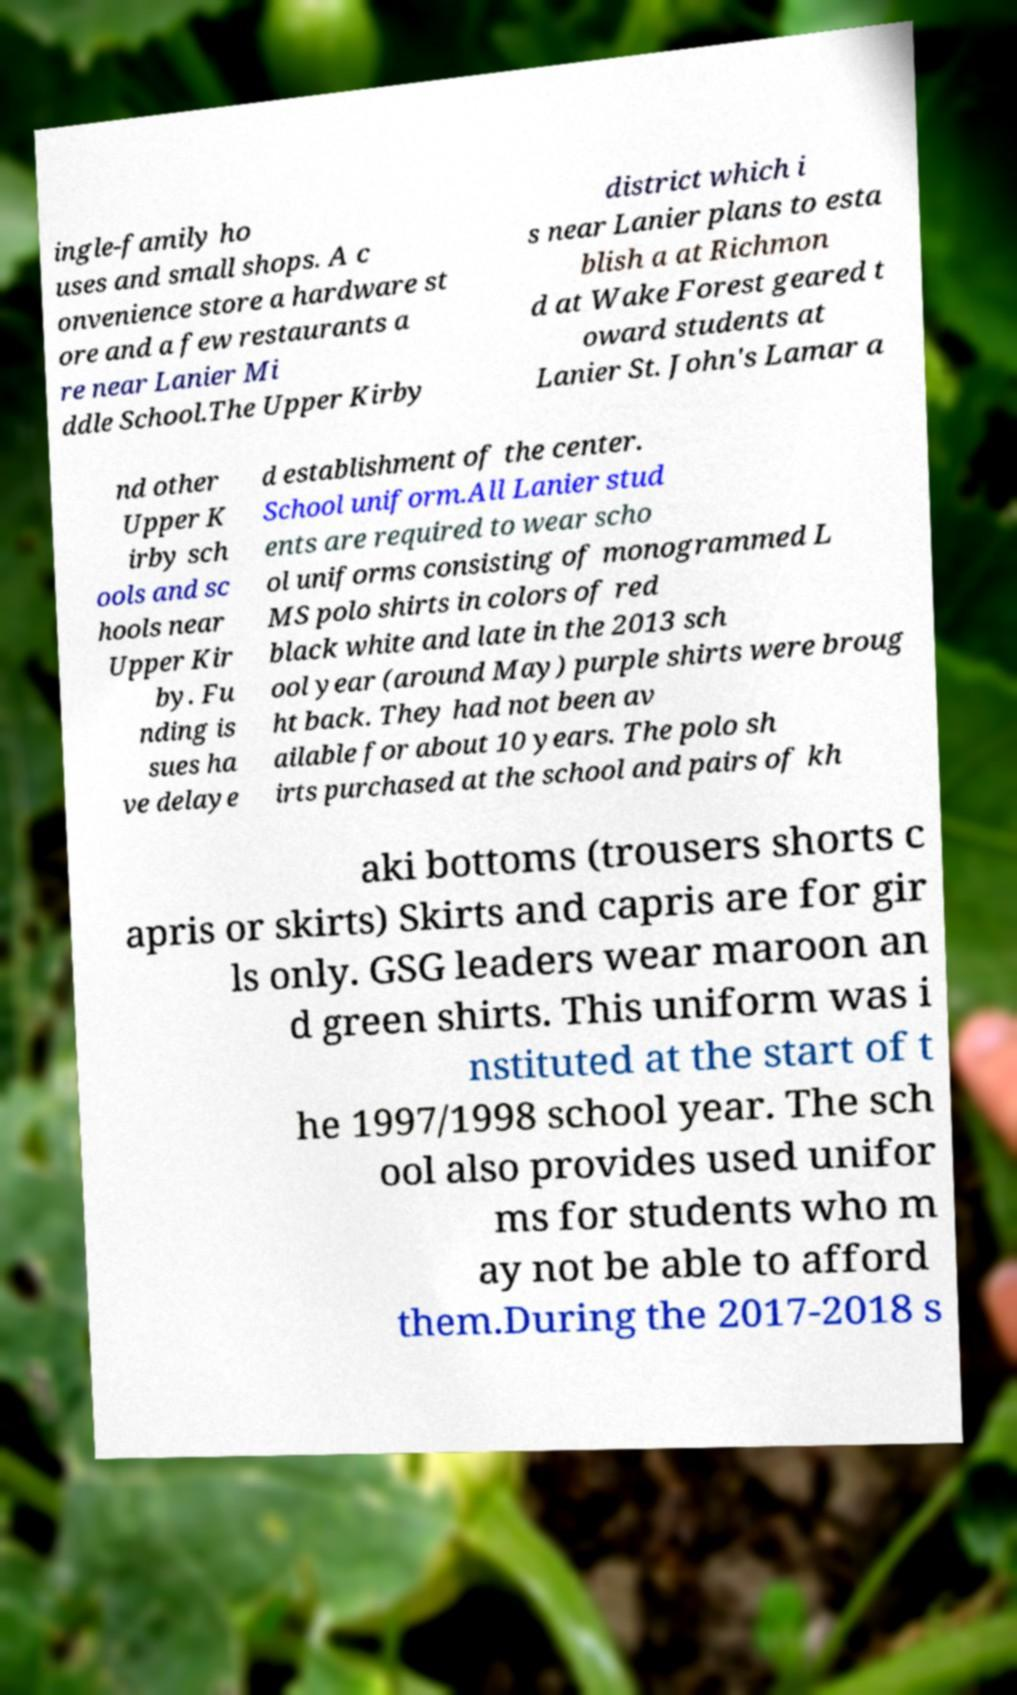There's text embedded in this image that I need extracted. Can you transcribe it verbatim? ingle-family ho uses and small shops. A c onvenience store a hardware st ore and a few restaurants a re near Lanier Mi ddle School.The Upper Kirby district which i s near Lanier plans to esta blish a at Richmon d at Wake Forest geared t oward students at Lanier St. John's Lamar a nd other Upper K irby sch ools and sc hools near Upper Kir by. Fu nding is sues ha ve delaye d establishment of the center. School uniform.All Lanier stud ents are required to wear scho ol uniforms consisting of monogrammed L MS polo shirts in colors of red black white and late in the 2013 sch ool year (around May) purple shirts were broug ht back. They had not been av ailable for about 10 years. The polo sh irts purchased at the school and pairs of kh aki bottoms (trousers shorts c apris or skirts) Skirts and capris are for gir ls only. GSG leaders wear maroon an d green shirts. This uniform was i nstituted at the start of t he 1997/1998 school year. The sch ool also provides used unifor ms for students who m ay not be able to afford them.During the 2017-2018 s 